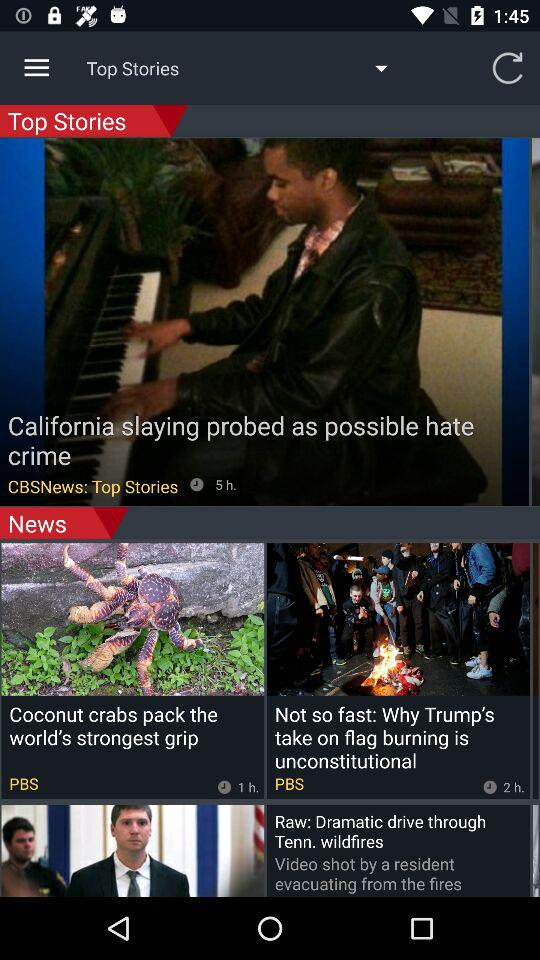When was the "Why Trump's take on flag burning is unconstitutional" news updated? The news was updated 2 hours ago. 